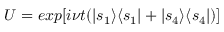<formula> <loc_0><loc_0><loc_500><loc_500>U = e x p [ i \nu t ( | s _ { 1 } \rangle \langle s _ { 1 } | + | s _ { 4 } \rangle \langle s _ { 4 } | ) ]</formula> 